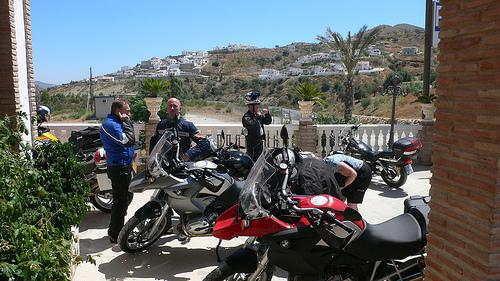Can you tell me more about the style or make of the motorcycles visible in this image? The motorcycles shown in the image include sports models and touring bikes. The designs suggest a mix of functionalities tailored for both speed on paved roads and comfort for long distances. 